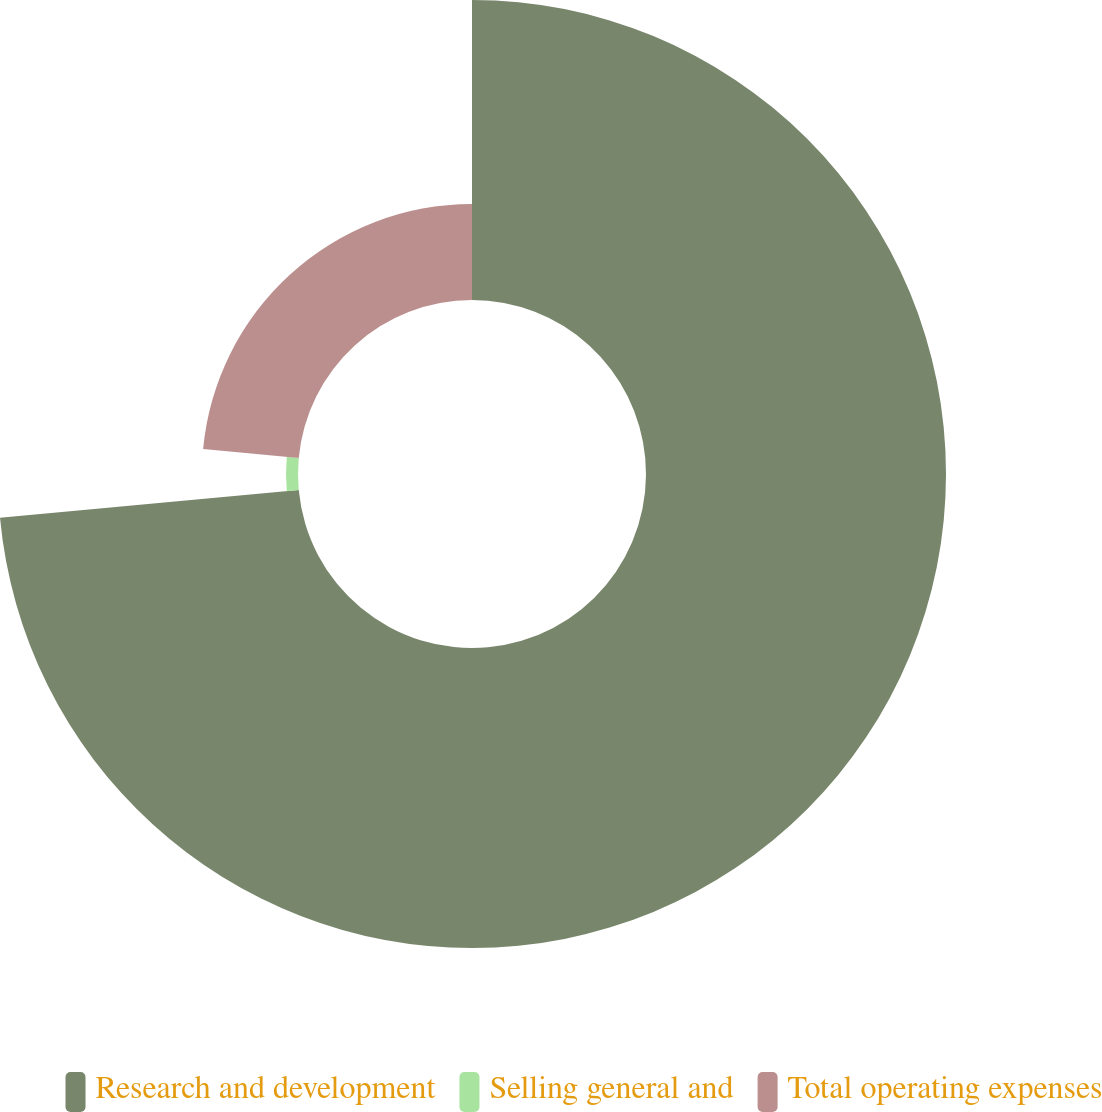<chart> <loc_0><loc_0><loc_500><loc_500><pie_chart><fcel>Research and development<fcel>Selling general and<fcel>Total operating expenses<nl><fcel>73.53%<fcel>2.94%<fcel>23.53%<nl></chart> 